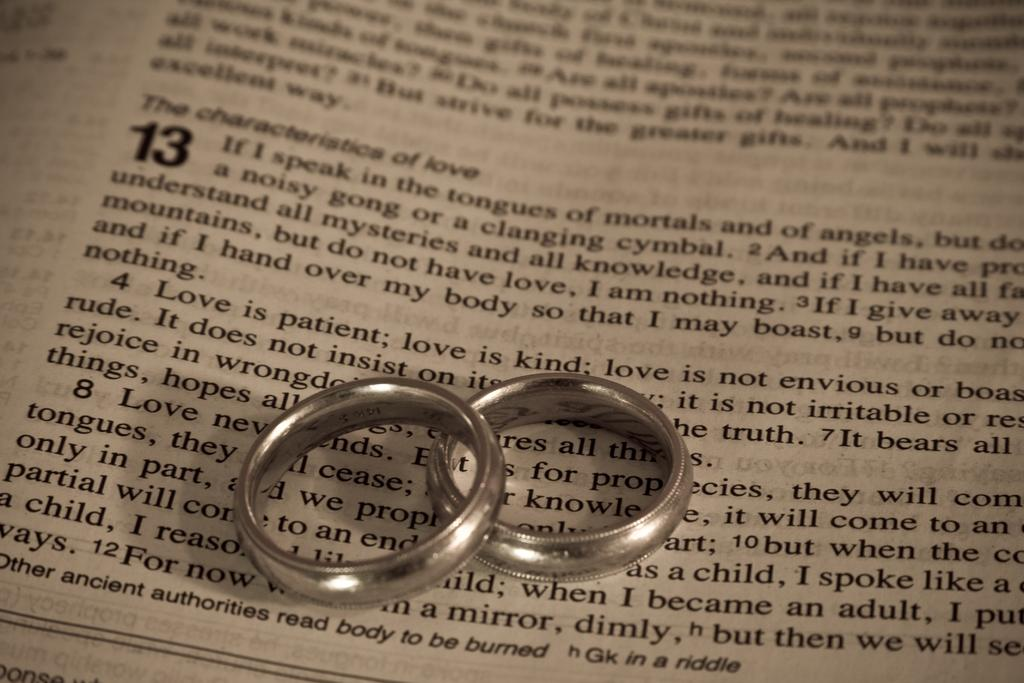<image>
Create a compact narrative representing the image presented. A page of a book is visible with a number of 13 at the start of a paragraph. 